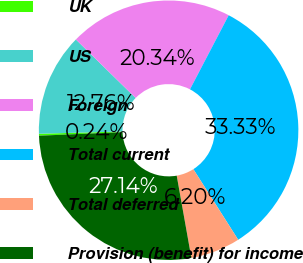<chart> <loc_0><loc_0><loc_500><loc_500><pie_chart><fcel>UK<fcel>US<fcel>Foreign<fcel>Total current<fcel>Total deferred<fcel>Provision (benefit) for income<nl><fcel>0.24%<fcel>12.76%<fcel>20.34%<fcel>33.33%<fcel>6.2%<fcel>27.14%<nl></chart> 